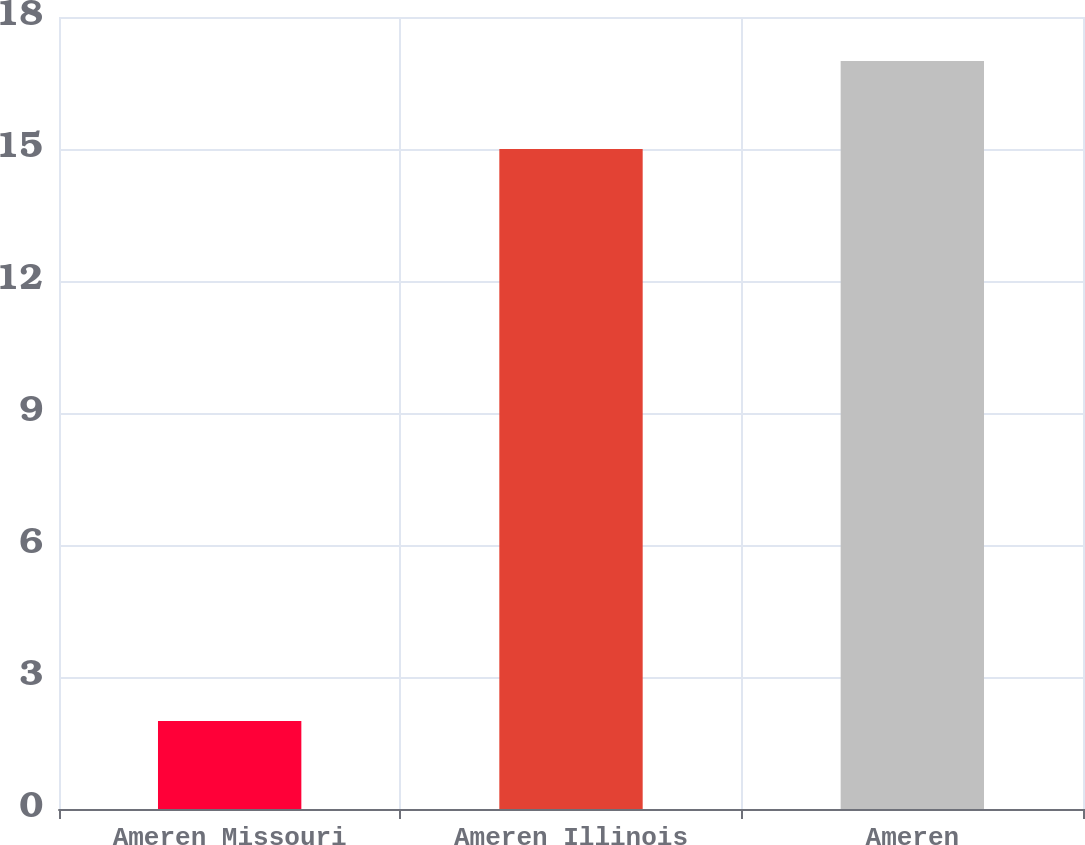Convert chart. <chart><loc_0><loc_0><loc_500><loc_500><bar_chart><fcel>Ameren Missouri<fcel>Ameren Illinois<fcel>Ameren<nl><fcel>2<fcel>15<fcel>17<nl></chart> 